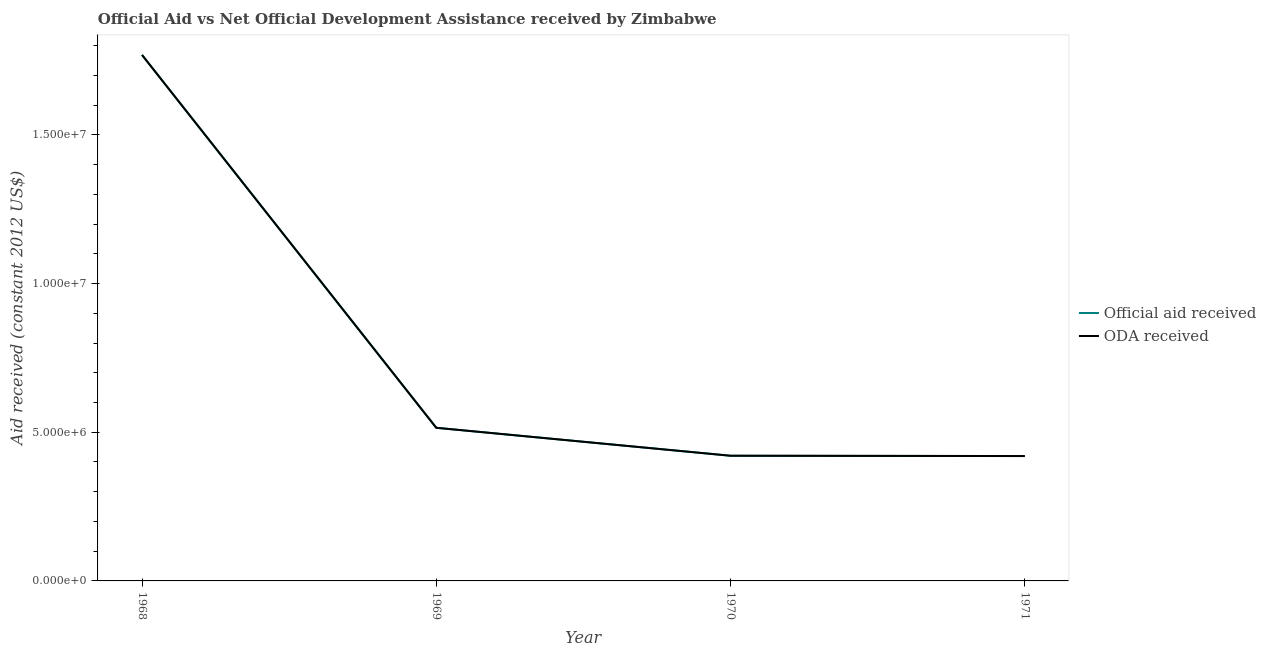Is the number of lines equal to the number of legend labels?
Offer a very short reply. Yes. What is the oda received in 1971?
Your answer should be compact. 4.20e+06. Across all years, what is the maximum official aid received?
Provide a short and direct response. 1.77e+07. Across all years, what is the minimum oda received?
Provide a succinct answer. 4.20e+06. In which year was the oda received maximum?
Your answer should be very brief. 1968. In which year was the official aid received minimum?
Your answer should be compact. 1971. What is the total official aid received in the graph?
Make the answer very short. 3.12e+07. What is the difference between the official aid received in 1968 and that in 1971?
Offer a terse response. 1.35e+07. What is the difference between the oda received in 1968 and the official aid received in 1970?
Your answer should be very brief. 1.35e+07. What is the average official aid received per year?
Ensure brevity in your answer.  7.81e+06. In how many years, is the official aid received greater than 16000000 US$?
Keep it short and to the point. 1. What is the ratio of the official aid received in 1968 to that in 1970?
Make the answer very short. 4.2. Is the difference between the official aid received in 1968 and 1970 greater than the difference between the oda received in 1968 and 1970?
Provide a succinct answer. No. What is the difference between the highest and the second highest oda received?
Make the answer very short. 1.25e+07. What is the difference between the highest and the lowest official aid received?
Offer a terse response. 1.35e+07. Is the oda received strictly greater than the official aid received over the years?
Provide a succinct answer. No. Is the oda received strictly less than the official aid received over the years?
Keep it short and to the point. No. How many lines are there?
Ensure brevity in your answer.  2. What is the difference between two consecutive major ticks on the Y-axis?
Your response must be concise. 5.00e+06. Are the values on the major ticks of Y-axis written in scientific E-notation?
Give a very brief answer. Yes. Does the graph contain grids?
Give a very brief answer. No. Where does the legend appear in the graph?
Your answer should be very brief. Center right. How many legend labels are there?
Ensure brevity in your answer.  2. How are the legend labels stacked?
Provide a short and direct response. Vertical. What is the title of the graph?
Your answer should be compact. Official Aid vs Net Official Development Assistance received by Zimbabwe . Does "Female labor force" appear as one of the legend labels in the graph?
Ensure brevity in your answer.  No. What is the label or title of the X-axis?
Your answer should be very brief. Year. What is the label or title of the Y-axis?
Provide a short and direct response. Aid received (constant 2012 US$). What is the Aid received (constant 2012 US$) in Official aid received in 1968?
Your answer should be compact. 1.77e+07. What is the Aid received (constant 2012 US$) of ODA received in 1968?
Give a very brief answer. 1.77e+07. What is the Aid received (constant 2012 US$) of Official aid received in 1969?
Provide a short and direct response. 5.15e+06. What is the Aid received (constant 2012 US$) of ODA received in 1969?
Ensure brevity in your answer.  5.15e+06. What is the Aid received (constant 2012 US$) of Official aid received in 1970?
Offer a very short reply. 4.21e+06. What is the Aid received (constant 2012 US$) in ODA received in 1970?
Keep it short and to the point. 4.21e+06. What is the Aid received (constant 2012 US$) in Official aid received in 1971?
Your response must be concise. 4.20e+06. What is the Aid received (constant 2012 US$) in ODA received in 1971?
Keep it short and to the point. 4.20e+06. Across all years, what is the maximum Aid received (constant 2012 US$) of Official aid received?
Provide a short and direct response. 1.77e+07. Across all years, what is the maximum Aid received (constant 2012 US$) of ODA received?
Your response must be concise. 1.77e+07. Across all years, what is the minimum Aid received (constant 2012 US$) in Official aid received?
Keep it short and to the point. 4.20e+06. Across all years, what is the minimum Aid received (constant 2012 US$) in ODA received?
Make the answer very short. 4.20e+06. What is the total Aid received (constant 2012 US$) of Official aid received in the graph?
Offer a very short reply. 3.12e+07. What is the total Aid received (constant 2012 US$) in ODA received in the graph?
Give a very brief answer. 3.12e+07. What is the difference between the Aid received (constant 2012 US$) of Official aid received in 1968 and that in 1969?
Keep it short and to the point. 1.25e+07. What is the difference between the Aid received (constant 2012 US$) in ODA received in 1968 and that in 1969?
Give a very brief answer. 1.25e+07. What is the difference between the Aid received (constant 2012 US$) of Official aid received in 1968 and that in 1970?
Provide a short and direct response. 1.35e+07. What is the difference between the Aid received (constant 2012 US$) in ODA received in 1968 and that in 1970?
Make the answer very short. 1.35e+07. What is the difference between the Aid received (constant 2012 US$) in Official aid received in 1968 and that in 1971?
Offer a very short reply. 1.35e+07. What is the difference between the Aid received (constant 2012 US$) in ODA received in 1968 and that in 1971?
Offer a very short reply. 1.35e+07. What is the difference between the Aid received (constant 2012 US$) of Official aid received in 1969 and that in 1970?
Your response must be concise. 9.40e+05. What is the difference between the Aid received (constant 2012 US$) in ODA received in 1969 and that in 1970?
Offer a very short reply. 9.40e+05. What is the difference between the Aid received (constant 2012 US$) of Official aid received in 1969 and that in 1971?
Your answer should be very brief. 9.50e+05. What is the difference between the Aid received (constant 2012 US$) of ODA received in 1969 and that in 1971?
Your answer should be very brief. 9.50e+05. What is the difference between the Aid received (constant 2012 US$) in Official aid received in 1970 and that in 1971?
Your answer should be very brief. 10000. What is the difference between the Aid received (constant 2012 US$) in Official aid received in 1968 and the Aid received (constant 2012 US$) in ODA received in 1969?
Your answer should be compact. 1.25e+07. What is the difference between the Aid received (constant 2012 US$) in Official aid received in 1968 and the Aid received (constant 2012 US$) in ODA received in 1970?
Ensure brevity in your answer.  1.35e+07. What is the difference between the Aid received (constant 2012 US$) of Official aid received in 1968 and the Aid received (constant 2012 US$) of ODA received in 1971?
Provide a short and direct response. 1.35e+07. What is the difference between the Aid received (constant 2012 US$) in Official aid received in 1969 and the Aid received (constant 2012 US$) in ODA received in 1970?
Your answer should be very brief. 9.40e+05. What is the difference between the Aid received (constant 2012 US$) of Official aid received in 1969 and the Aid received (constant 2012 US$) of ODA received in 1971?
Ensure brevity in your answer.  9.50e+05. What is the difference between the Aid received (constant 2012 US$) of Official aid received in 1970 and the Aid received (constant 2012 US$) of ODA received in 1971?
Provide a short and direct response. 10000. What is the average Aid received (constant 2012 US$) in Official aid received per year?
Give a very brief answer. 7.81e+06. What is the average Aid received (constant 2012 US$) in ODA received per year?
Offer a terse response. 7.81e+06. In the year 1969, what is the difference between the Aid received (constant 2012 US$) of Official aid received and Aid received (constant 2012 US$) of ODA received?
Make the answer very short. 0. What is the ratio of the Aid received (constant 2012 US$) of Official aid received in 1968 to that in 1969?
Offer a terse response. 3.44. What is the ratio of the Aid received (constant 2012 US$) of ODA received in 1968 to that in 1969?
Offer a very short reply. 3.44. What is the ratio of the Aid received (constant 2012 US$) of Official aid received in 1968 to that in 1970?
Give a very brief answer. 4.2. What is the ratio of the Aid received (constant 2012 US$) of ODA received in 1968 to that in 1970?
Provide a short and direct response. 4.2. What is the ratio of the Aid received (constant 2012 US$) of Official aid received in 1968 to that in 1971?
Offer a very short reply. 4.21. What is the ratio of the Aid received (constant 2012 US$) of ODA received in 1968 to that in 1971?
Your answer should be very brief. 4.21. What is the ratio of the Aid received (constant 2012 US$) of Official aid received in 1969 to that in 1970?
Provide a succinct answer. 1.22. What is the ratio of the Aid received (constant 2012 US$) of ODA received in 1969 to that in 1970?
Provide a short and direct response. 1.22. What is the ratio of the Aid received (constant 2012 US$) in Official aid received in 1969 to that in 1971?
Ensure brevity in your answer.  1.23. What is the ratio of the Aid received (constant 2012 US$) of ODA received in 1969 to that in 1971?
Keep it short and to the point. 1.23. What is the ratio of the Aid received (constant 2012 US$) in Official aid received in 1970 to that in 1971?
Provide a short and direct response. 1. What is the difference between the highest and the second highest Aid received (constant 2012 US$) of Official aid received?
Keep it short and to the point. 1.25e+07. What is the difference between the highest and the second highest Aid received (constant 2012 US$) of ODA received?
Offer a very short reply. 1.25e+07. What is the difference between the highest and the lowest Aid received (constant 2012 US$) of Official aid received?
Offer a terse response. 1.35e+07. What is the difference between the highest and the lowest Aid received (constant 2012 US$) of ODA received?
Give a very brief answer. 1.35e+07. 